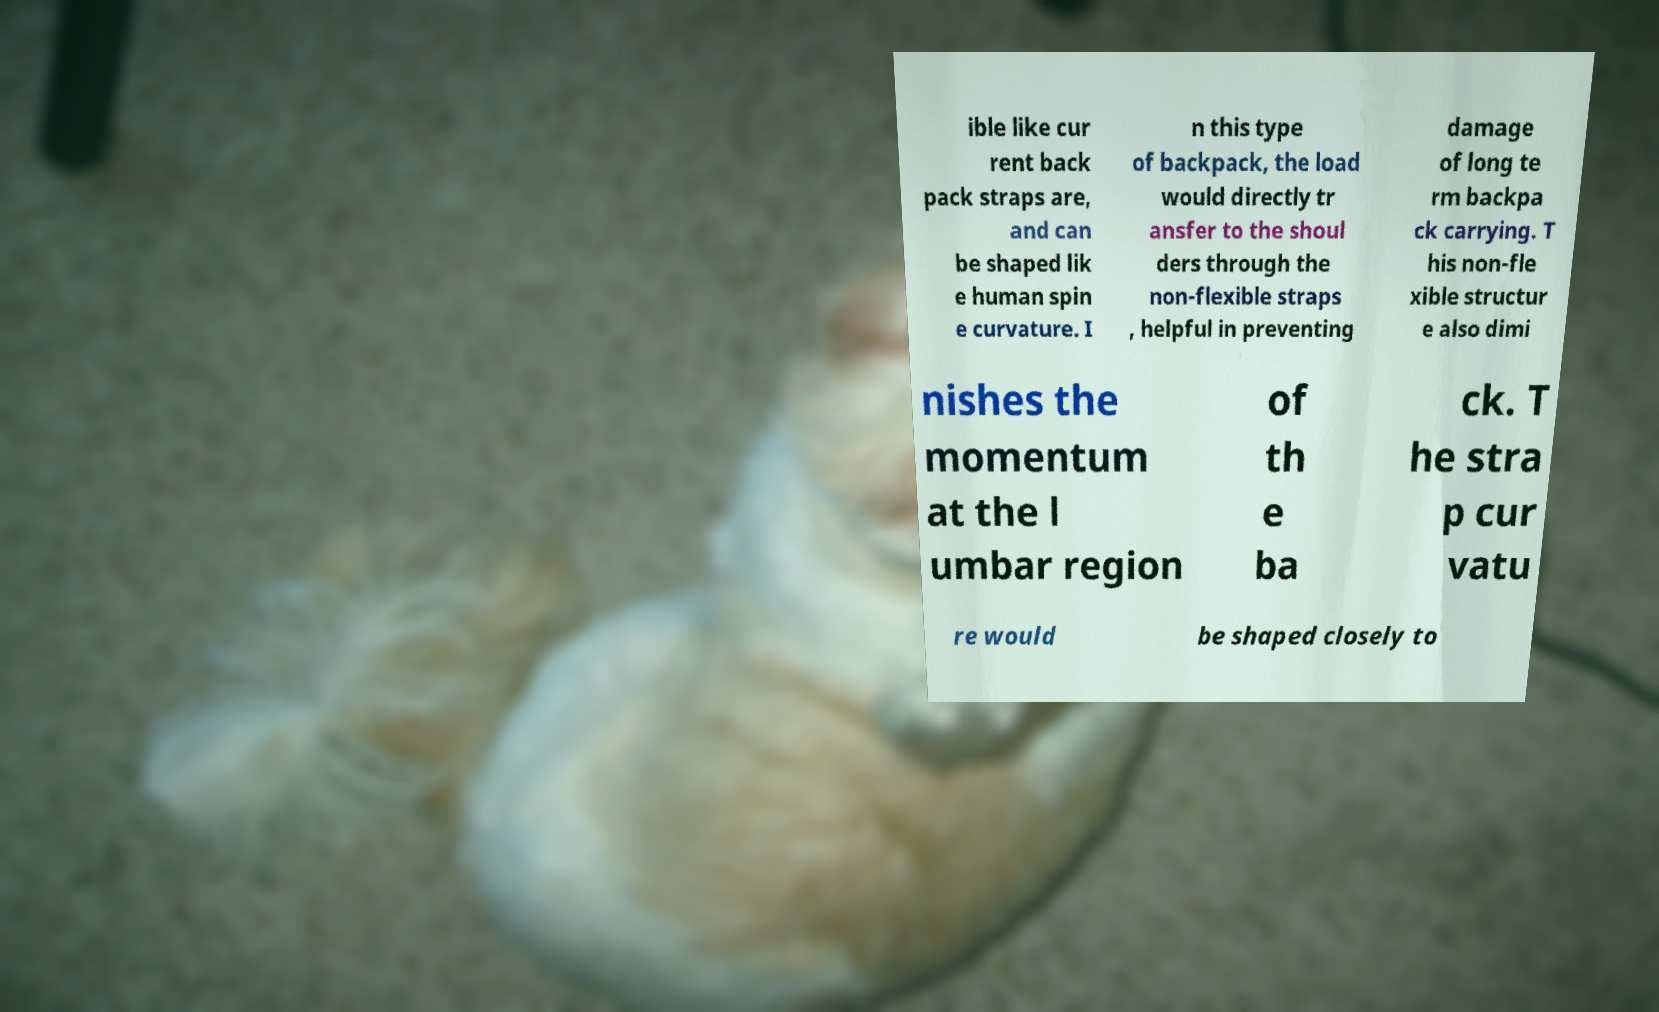Please read and relay the text visible in this image. What does it say? ible like cur rent back pack straps are, and can be shaped lik e human spin e curvature. I n this type of backpack, the load would directly tr ansfer to the shoul ders through the non-flexible straps , helpful in preventing damage of long te rm backpa ck carrying. T his non-fle xible structur e also dimi nishes the momentum at the l umbar region of th e ba ck. T he stra p cur vatu re would be shaped closely to 